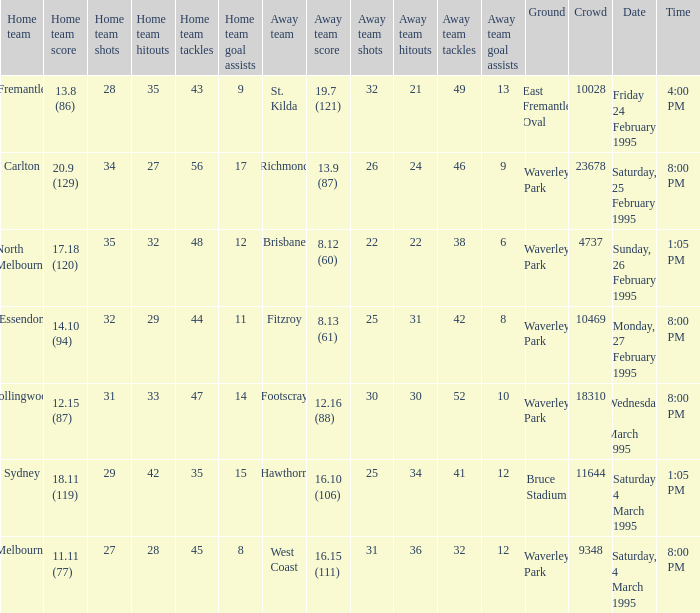Name the ground for essendon Waverley Park. 